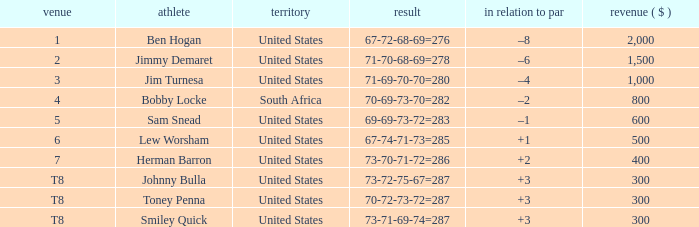What is the Score of the game of the Player in Place 4? 70-69-73-70=282. 